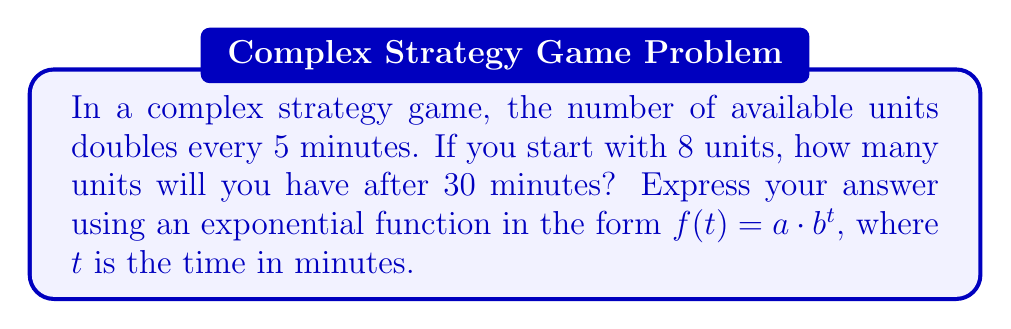Teach me how to tackle this problem. Let's approach this step-by-step:

1) First, we need to identify the components of our exponential function:
   - $a$ is the initial number of units (8)
   - $b$ is the growth factor for each time period
   - $t$ is the time in minutes

2) We're told that the number of units doubles every 5 minutes. This means that in 30 minutes, there will be 6 doubling periods (30 ÷ 5 = 6).

3) To find $b$, we need to determine the growth factor for 1 minute:
   $b = 2^{\frac{1}{5}} \approx 1.1487$

4) Now we can write our function:
   $f(t) = 8 \cdot (1.1487)^t$

5) To find the number of units after 30 minutes, we calculate:
   $f(30) = 8 \cdot (1.1487)^{30} \approx 256$

6) We can verify this:
   $8 \cdot 2^6 = 8 \cdot 64 = 512$

   Indeed, doubling 6 times (every 5 minutes for 30 minutes) gives us 512 units.

Therefore, the exponential function representing the growth of units over time is:

$$f(t) = 8 \cdot (2^{\frac{1}{5}})^t$$

Where $t$ is the time in minutes.
Answer: $f(t) = 8 \cdot (2^{\frac{1}{5}})^t$ 